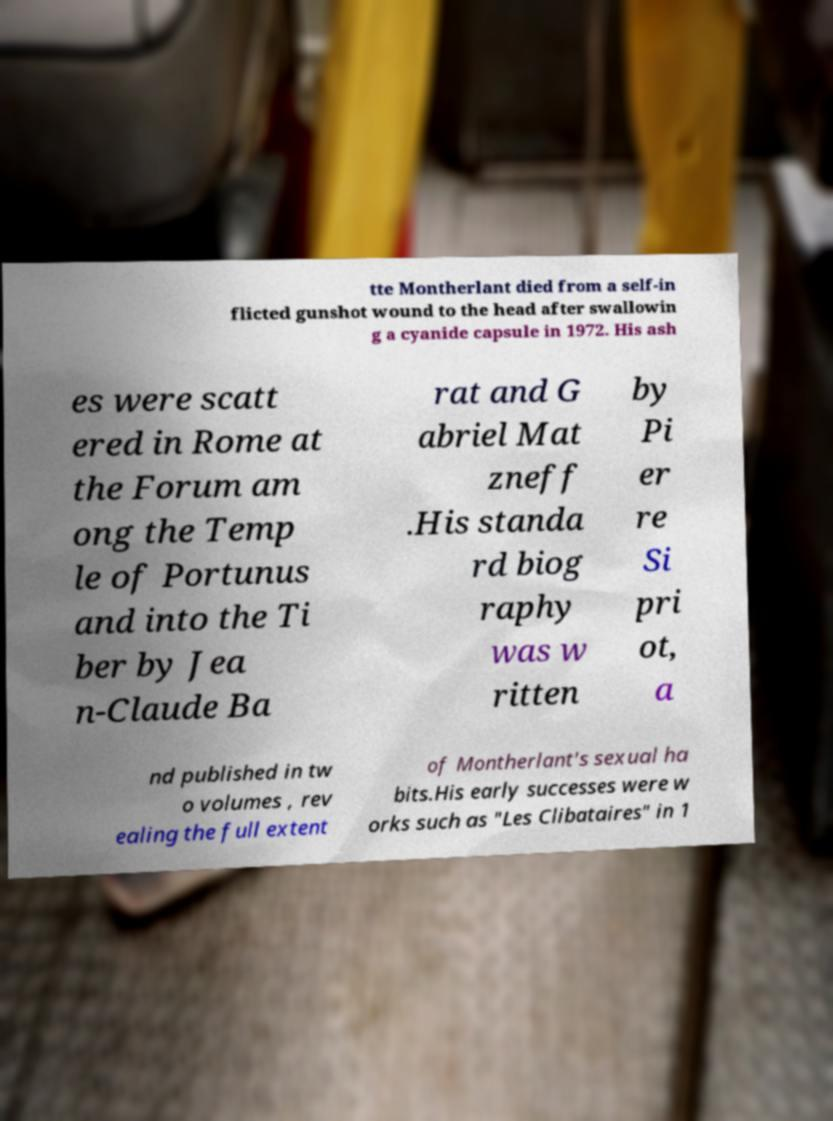What messages or text are displayed in this image? I need them in a readable, typed format. tte Montherlant died from a self-in flicted gunshot wound to the head after swallowin g a cyanide capsule in 1972. His ash es were scatt ered in Rome at the Forum am ong the Temp le of Portunus and into the Ti ber by Jea n-Claude Ba rat and G abriel Mat zneff .His standa rd biog raphy was w ritten by Pi er re Si pri ot, a nd published in tw o volumes , rev ealing the full extent of Montherlant's sexual ha bits.His early successes were w orks such as "Les Clibataires" in 1 